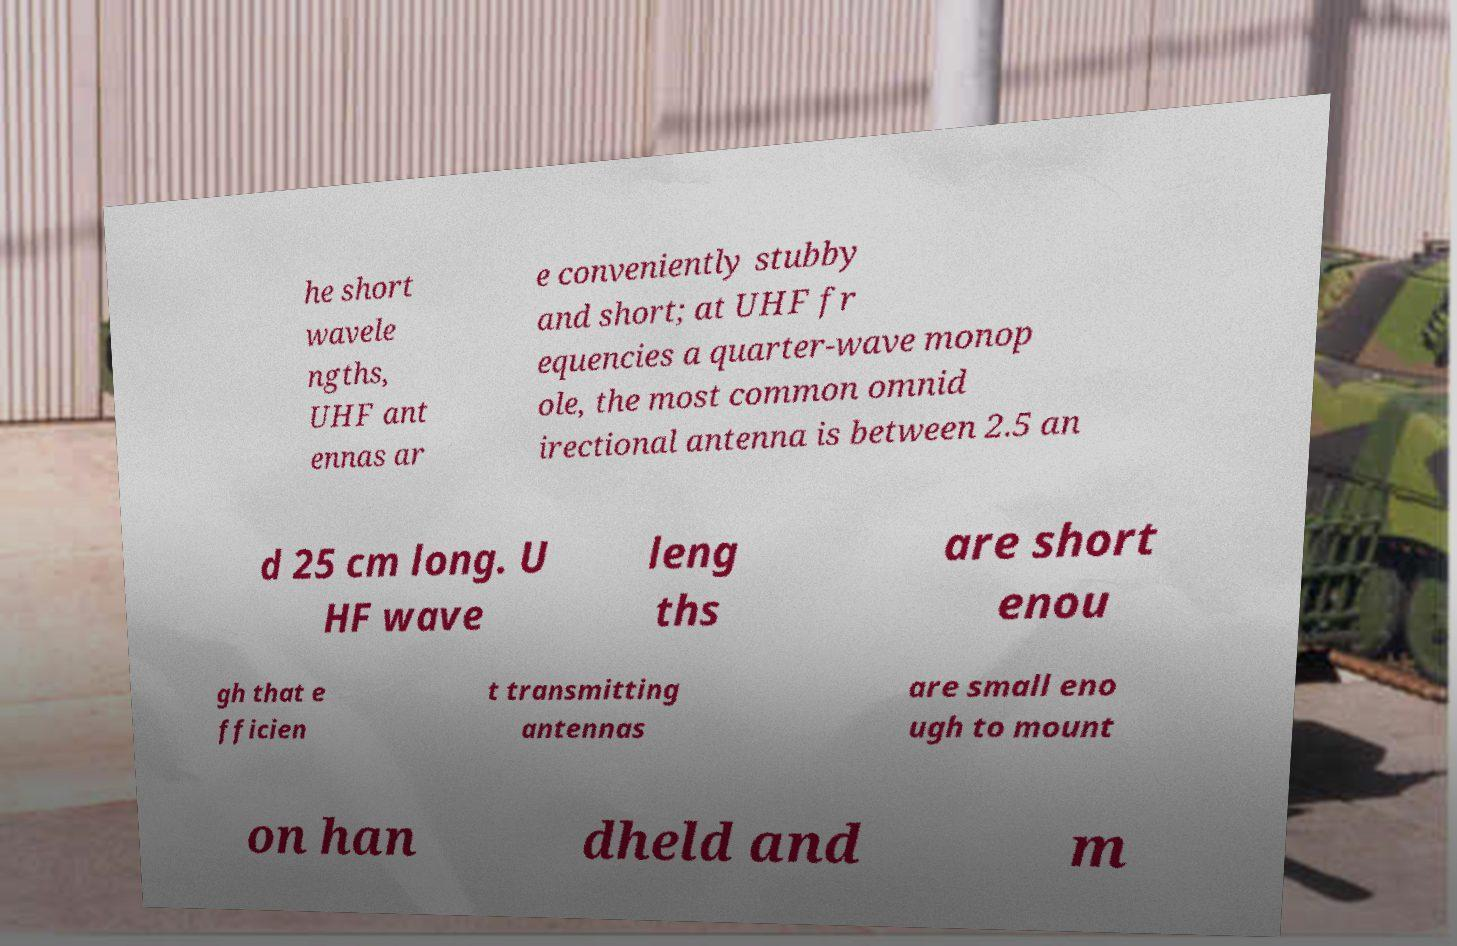Could you extract and type out the text from this image? he short wavele ngths, UHF ant ennas ar e conveniently stubby and short; at UHF fr equencies a quarter-wave monop ole, the most common omnid irectional antenna is between 2.5 an d 25 cm long. U HF wave leng ths are short enou gh that e fficien t transmitting antennas are small eno ugh to mount on han dheld and m 